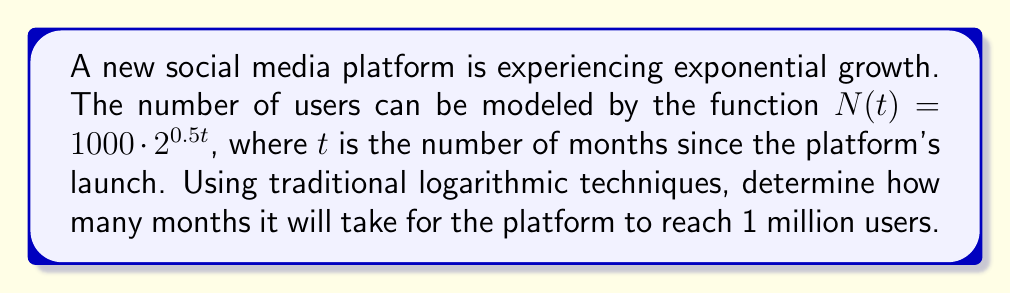Give your solution to this math problem. To solve this problem using traditional logarithmic techniques, we'll follow these steps:

1) We want to find $t$ when $N(t) = 1,000,000$. So, we set up the equation:

   $1,000,000 = 1000 \cdot 2^{0.5t}$

2) Divide both sides by 1000:

   $1,000 = 2^{0.5t}$

3) Now, we apply the logarithm (base 2) to both sides:

   $\log_2(1,000) = \log_2(2^{0.5t})$

4) Using the logarithm property $\log_a(a^x) = x$, we simplify the right side:

   $\log_2(1,000) = 0.5t$

5) Now, we can solve for $t$:

   $t = \frac{\log_2(1,000)}{0.5}$

6) To calculate $\log_2(1,000)$, we can use the change of base formula:

   $\log_2(1,000) = \frac{\log(1,000)}{\log(2)}$

7) Using a calculator or logarithm tables:

   $t = \frac{\frac{\log(1,000)}{\log(2)}}{0.5} \approx 19.93$

8) Since we're dealing with whole months, we round up to the next integer.
Answer: It will take 20 months for the platform to reach 1 million users. 